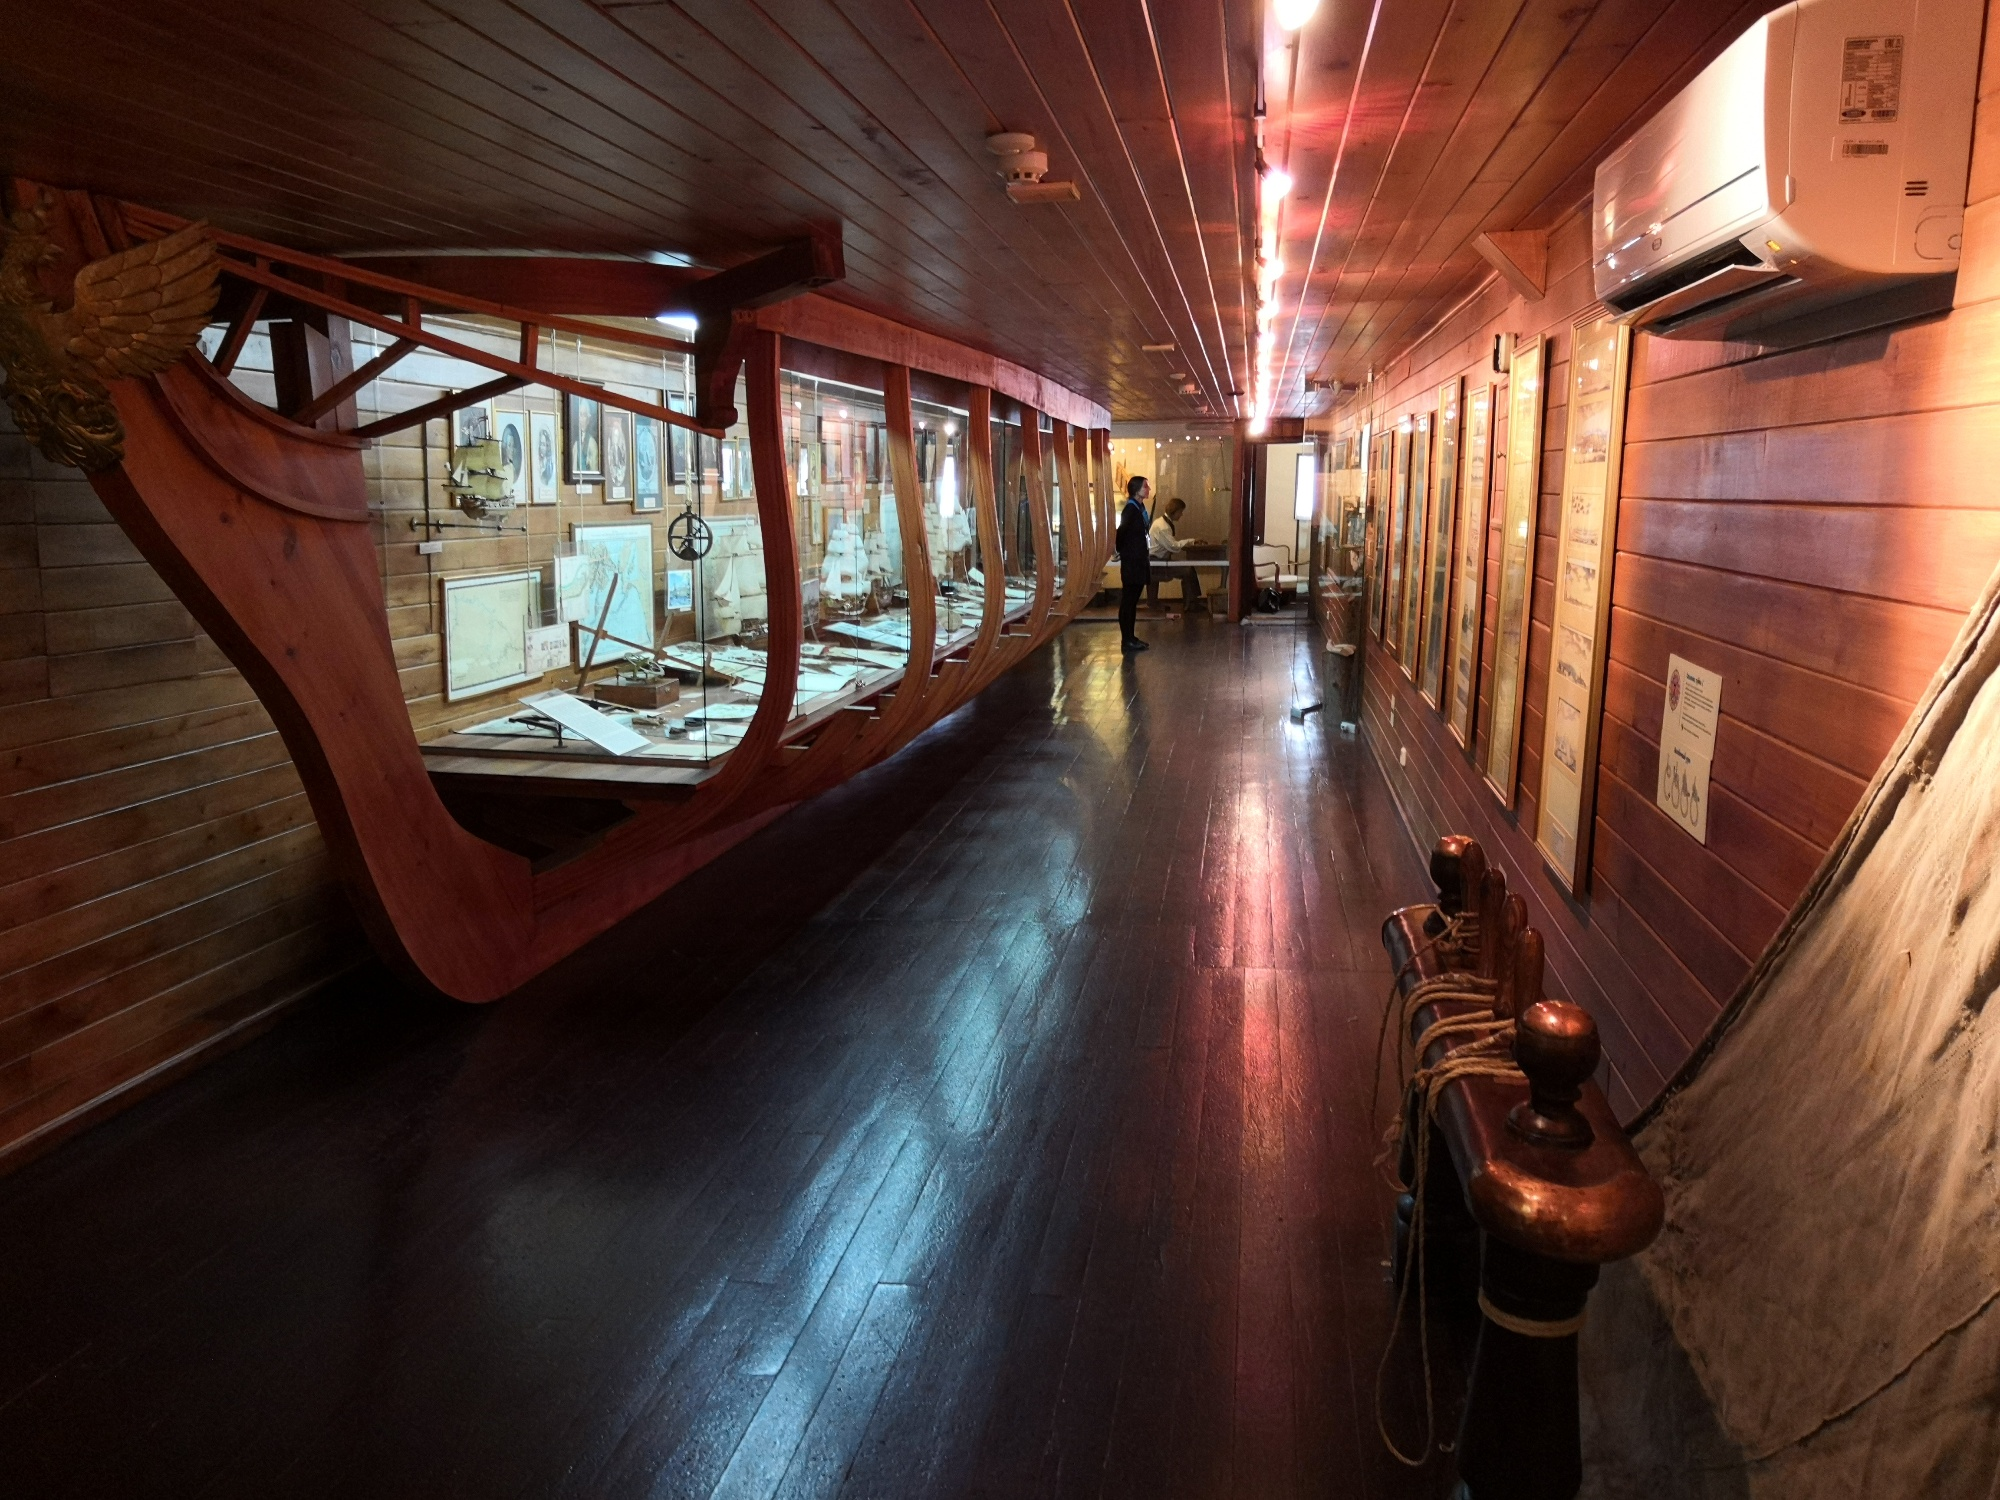What's happening in the scene? The image showcases a richly detailed interior of a museum exhibit, designed to resemble the bow section of a historical ship, likely a replica of the Santa Maria, the flagship of Christopher Columbus's first voyage across the Atlantic in 1492. The interior is lined with wooden panels, and the ship’s framework encloses various historical artifacts and display cases filled with maps, nautical instruments, and replicas of ships. A person is seen in the background, attentively examining one of the exhibits. The lighting is dim yet warm, casting a serene and slightly mysterious ambiance over the exhibit. Along the passage, ropes and maritime equipment are neatly arranged, recalling the operational aspects of seafaring life. This scene invites visitors to engage deeply with the rich maritime history, offering a tangible connection to the past. 